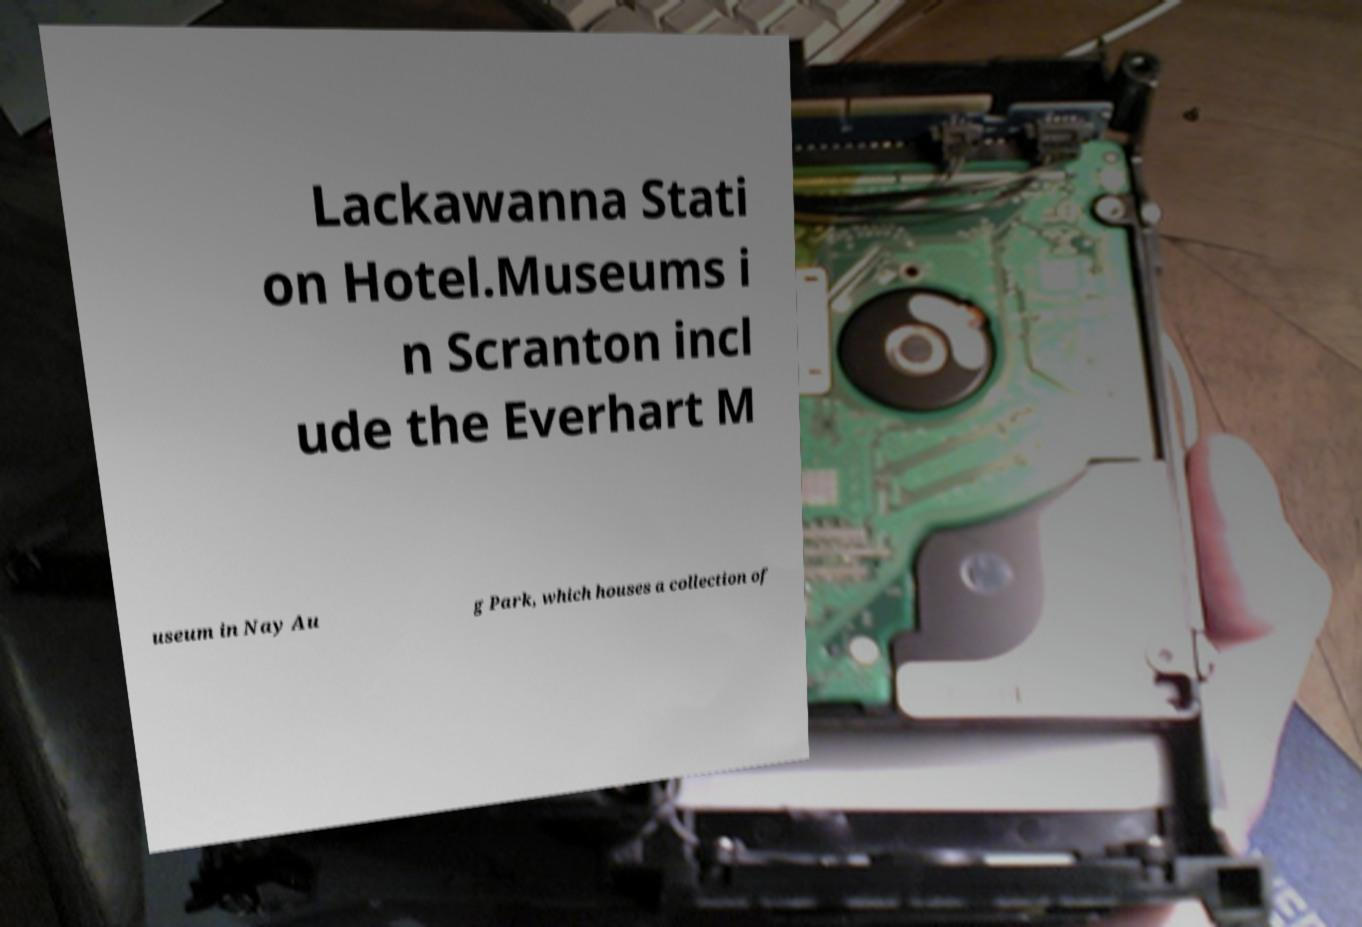I need the written content from this picture converted into text. Can you do that? Lackawanna Stati on Hotel.Museums i n Scranton incl ude the Everhart M useum in Nay Au g Park, which houses a collection of 